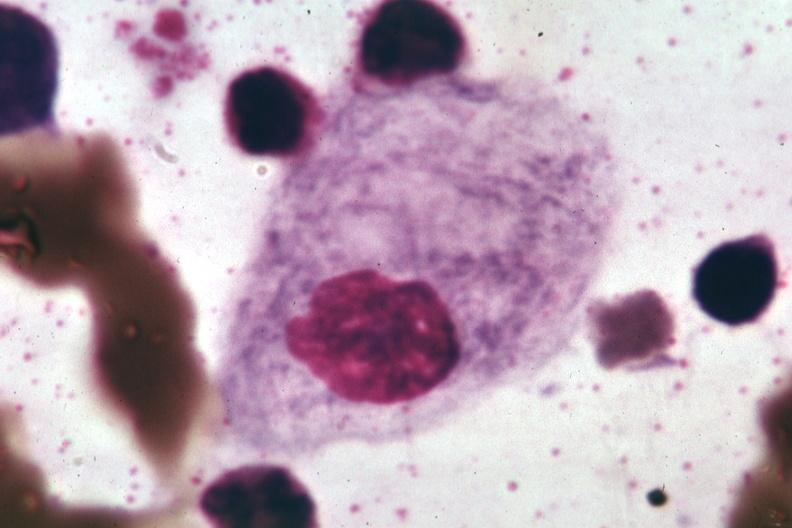what does this image show?
Answer the question using a single word or phrase. Wrights 